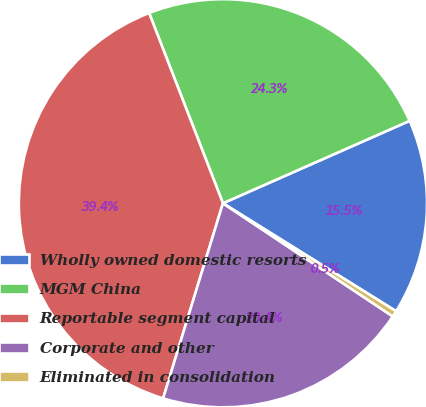Convert chart to OTSL. <chart><loc_0><loc_0><loc_500><loc_500><pie_chart><fcel>Wholly owned domestic resorts<fcel>MGM China<fcel>Reportable segment capital<fcel>Corporate and other<fcel>Eliminated in consolidation<nl><fcel>15.49%<fcel>24.27%<fcel>39.37%<fcel>20.38%<fcel>0.48%<nl></chart> 